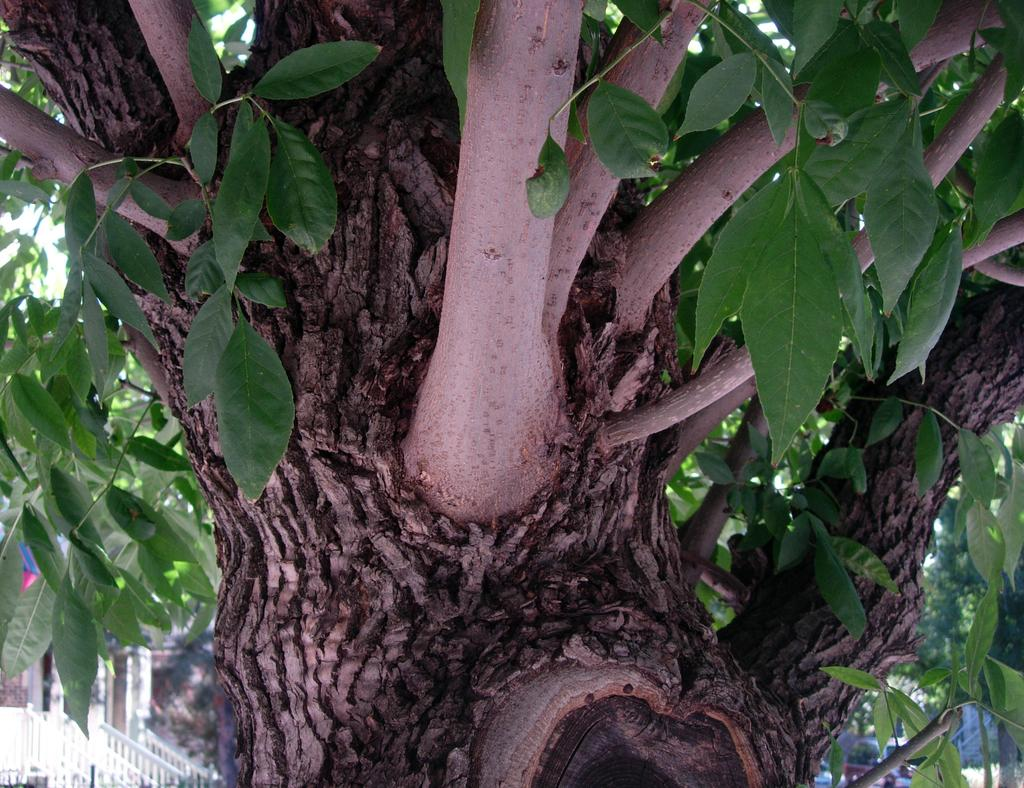What type of plant can be seen in the image? There is a tree in the image. Can you describe the tree's appearance? The tree has branches and leaves. What else is present in the image besides the tree? There is a vehicle and a fence in the image. What type of roof can be seen on the tree in the image? There is no roof present on the tree in the image; it is a natural tree with branches and leaves. 